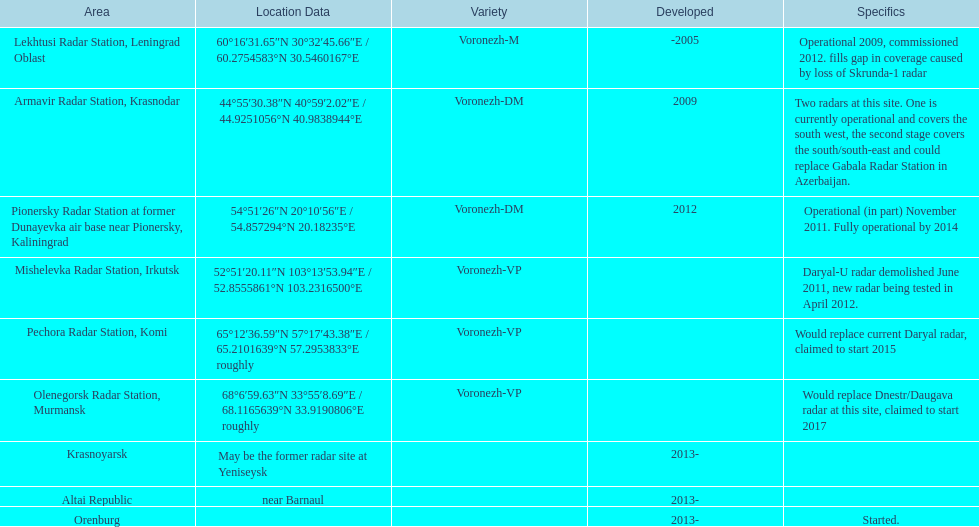Parse the table in full. {'header': ['Area', 'Location Data', 'Variety', 'Developed', 'Specifics'], 'rows': [['Lekhtusi Radar Station, Leningrad Oblast', '60°16′31.65″N 30°32′45.66″E\ufeff / \ufeff60.2754583°N 30.5460167°E', 'Voronezh-M', '-2005', 'Operational 2009, commissioned 2012. fills gap in coverage caused by loss of Skrunda-1 radar'], ['Armavir Radar Station, Krasnodar', '44°55′30.38″N 40°59′2.02″E\ufeff / \ufeff44.9251056°N 40.9838944°E', 'Voronezh-DM', '2009', 'Two radars at this site. One is currently operational and covers the south west, the second stage covers the south/south-east and could replace Gabala Radar Station in Azerbaijan.'], ['Pionersky Radar Station at former Dunayevka air base near Pionersky, Kaliningrad', '54°51′26″N 20°10′56″E\ufeff / \ufeff54.857294°N 20.18235°E', 'Voronezh-DM', '2012', 'Operational (in part) November 2011. Fully operational by 2014'], ['Mishelevka Radar Station, Irkutsk', '52°51′20.11″N 103°13′53.94″E\ufeff / \ufeff52.8555861°N 103.2316500°E', 'Voronezh-VP', '', 'Daryal-U radar demolished June 2011, new radar being tested in April 2012.'], ['Pechora Radar Station, Komi', '65°12′36.59″N 57°17′43.38″E\ufeff / \ufeff65.2101639°N 57.2953833°E roughly', 'Voronezh-VP', '', 'Would replace current Daryal radar, claimed to start 2015'], ['Olenegorsk Radar Station, Murmansk', '68°6′59.63″N 33°55′8.69″E\ufeff / \ufeff68.1165639°N 33.9190806°E roughly', 'Voronezh-VP', '', 'Would replace Dnestr/Daugava radar at this site, claimed to start 2017'], ['Krasnoyarsk', 'May be the former radar site at Yeniseysk', '', '2013-', ''], ['Altai Republic', 'near Barnaul', '', '2013-', ''], ['Orenburg', '', '', '2013-', 'Started.']]} What is the only location with a coordination of 60°16&#8242;31.65&#8243;n 30°32&#8242;45.66&#8243;e / 60.2754583°n 30.5460167°e? Lekhtusi Radar Station, Leningrad Oblast. 